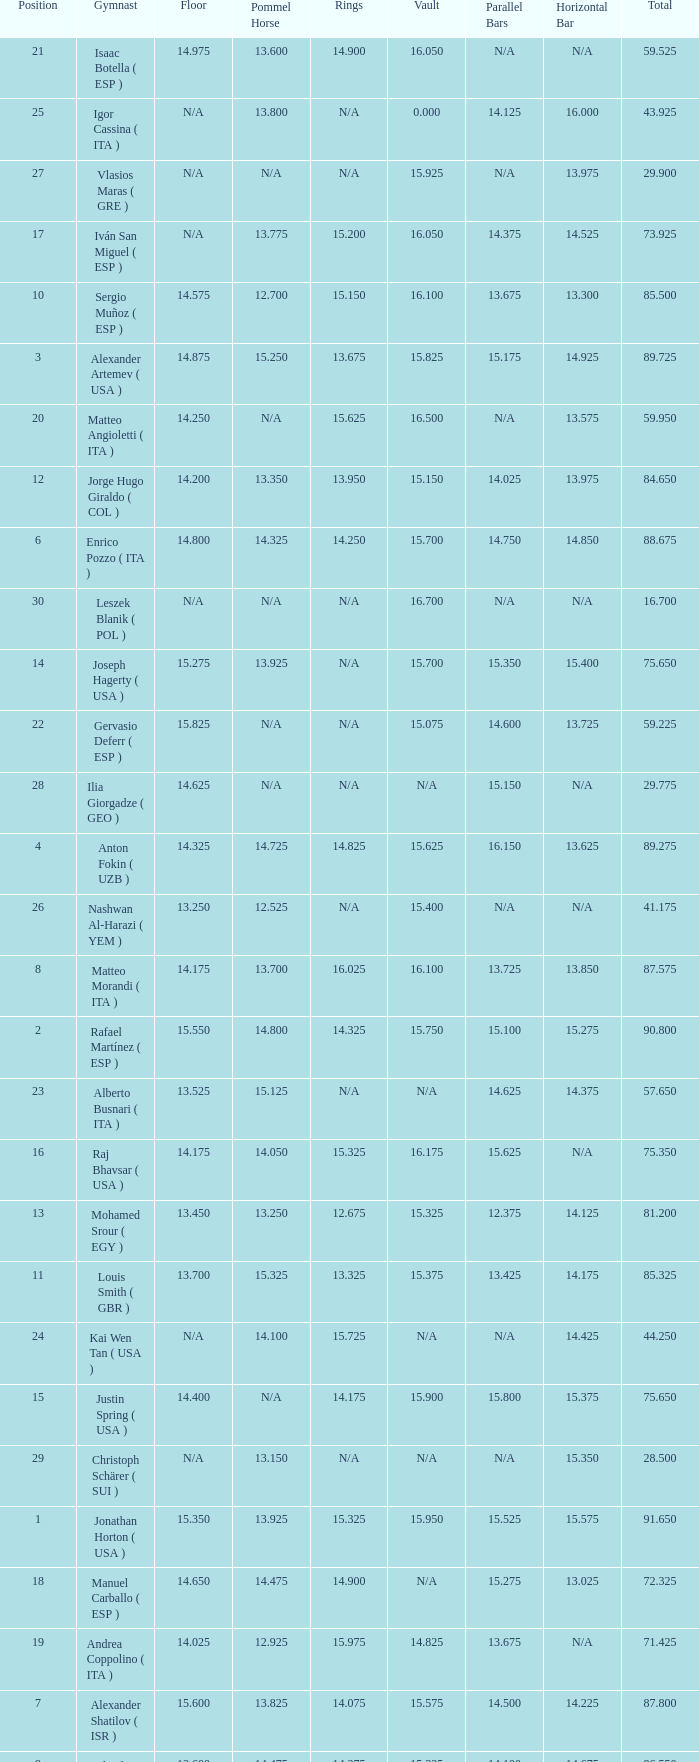If the floor number is 14.200, what is the number for the parallel bars? 14.025. 